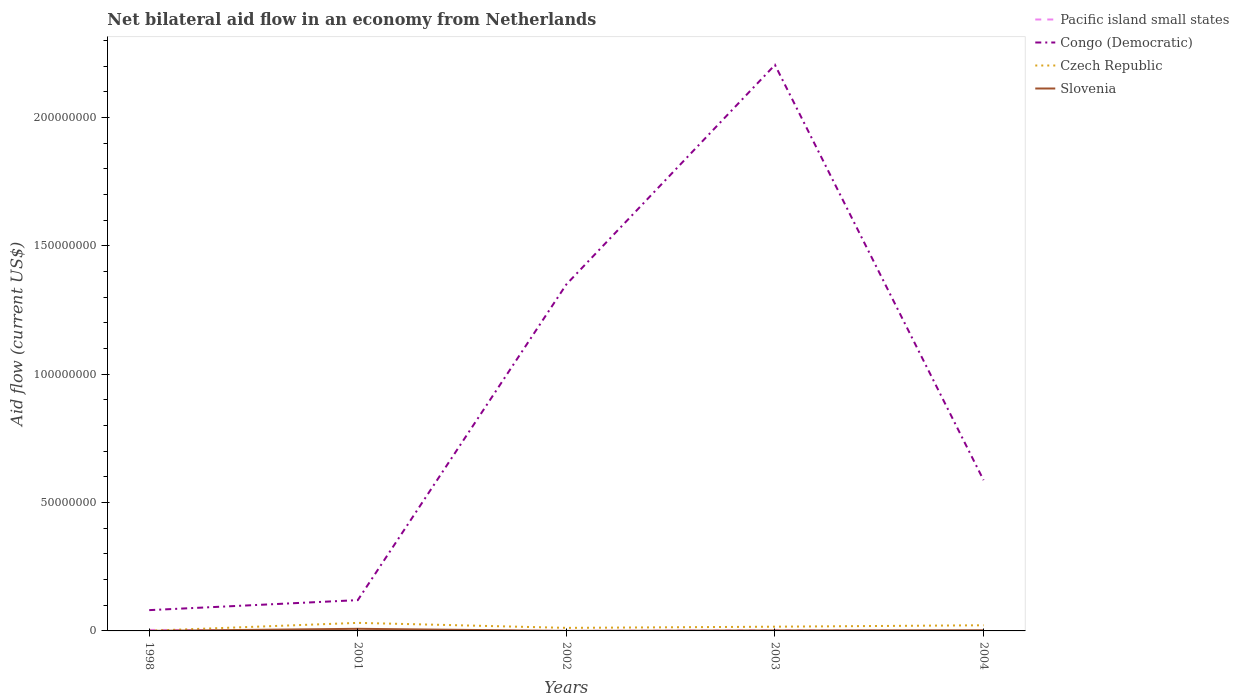How many different coloured lines are there?
Give a very brief answer. 4. Across all years, what is the maximum net bilateral aid flow in Slovenia?
Offer a terse response. 10000. What is the total net bilateral aid flow in Slovenia in the graph?
Make the answer very short. 5.60e+05. What is the difference between the highest and the lowest net bilateral aid flow in Czech Republic?
Make the answer very short. 2. How many years are there in the graph?
Provide a short and direct response. 5. Does the graph contain grids?
Give a very brief answer. No. Where does the legend appear in the graph?
Provide a succinct answer. Top right. What is the title of the graph?
Offer a terse response. Net bilateral aid flow in an economy from Netherlands. What is the label or title of the X-axis?
Give a very brief answer. Years. What is the Aid flow (current US$) in Pacific island small states in 1998?
Your response must be concise. 3.90e+05. What is the Aid flow (current US$) of Congo (Democratic) in 1998?
Provide a short and direct response. 8.10e+06. What is the Aid flow (current US$) in Czech Republic in 1998?
Offer a very short reply. 7.00e+04. What is the Aid flow (current US$) of Pacific island small states in 2001?
Provide a succinct answer. 1.80e+05. What is the Aid flow (current US$) of Congo (Democratic) in 2001?
Provide a short and direct response. 1.20e+07. What is the Aid flow (current US$) in Czech Republic in 2001?
Provide a short and direct response. 3.14e+06. What is the Aid flow (current US$) of Slovenia in 2001?
Make the answer very short. 8.20e+05. What is the Aid flow (current US$) in Pacific island small states in 2002?
Offer a very short reply. 10000. What is the Aid flow (current US$) of Congo (Democratic) in 2002?
Make the answer very short. 1.35e+08. What is the Aid flow (current US$) of Czech Republic in 2002?
Provide a succinct answer. 1.19e+06. What is the Aid flow (current US$) in Slovenia in 2002?
Provide a succinct answer. 10000. What is the Aid flow (current US$) in Congo (Democratic) in 2003?
Offer a terse response. 2.21e+08. What is the Aid flow (current US$) in Czech Republic in 2003?
Keep it short and to the point. 1.65e+06. What is the Aid flow (current US$) in Slovenia in 2003?
Provide a short and direct response. 1.90e+05. What is the Aid flow (current US$) of Pacific island small states in 2004?
Your answer should be very brief. 0. What is the Aid flow (current US$) in Congo (Democratic) in 2004?
Keep it short and to the point. 5.88e+07. What is the Aid flow (current US$) of Czech Republic in 2004?
Ensure brevity in your answer.  2.20e+06. Across all years, what is the maximum Aid flow (current US$) of Congo (Democratic)?
Ensure brevity in your answer.  2.21e+08. Across all years, what is the maximum Aid flow (current US$) in Czech Republic?
Ensure brevity in your answer.  3.14e+06. Across all years, what is the maximum Aid flow (current US$) of Slovenia?
Ensure brevity in your answer.  8.20e+05. Across all years, what is the minimum Aid flow (current US$) in Congo (Democratic)?
Ensure brevity in your answer.  8.10e+06. Across all years, what is the minimum Aid flow (current US$) in Slovenia?
Your answer should be very brief. 10000. What is the total Aid flow (current US$) of Pacific island small states in the graph?
Give a very brief answer. 7.60e+05. What is the total Aid flow (current US$) of Congo (Democratic) in the graph?
Your response must be concise. 4.34e+08. What is the total Aid flow (current US$) of Czech Republic in the graph?
Keep it short and to the point. 8.25e+06. What is the total Aid flow (current US$) of Slovenia in the graph?
Keep it short and to the point. 1.29e+06. What is the difference between the Aid flow (current US$) in Congo (Democratic) in 1998 and that in 2001?
Keep it short and to the point. -3.90e+06. What is the difference between the Aid flow (current US$) of Czech Republic in 1998 and that in 2001?
Your answer should be very brief. -3.07e+06. What is the difference between the Aid flow (current US$) in Slovenia in 1998 and that in 2001?
Keep it short and to the point. -8.10e+05. What is the difference between the Aid flow (current US$) of Congo (Democratic) in 1998 and that in 2002?
Make the answer very short. -1.27e+08. What is the difference between the Aid flow (current US$) in Czech Republic in 1998 and that in 2002?
Offer a very short reply. -1.12e+06. What is the difference between the Aid flow (current US$) of Congo (Democratic) in 1998 and that in 2003?
Provide a succinct answer. -2.12e+08. What is the difference between the Aid flow (current US$) of Czech Republic in 1998 and that in 2003?
Keep it short and to the point. -1.58e+06. What is the difference between the Aid flow (current US$) of Congo (Democratic) in 1998 and that in 2004?
Your answer should be very brief. -5.06e+07. What is the difference between the Aid flow (current US$) of Czech Republic in 1998 and that in 2004?
Offer a very short reply. -2.13e+06. What is the difference between the Aid flow (current US$) in Pacific island small states in 2001 and that in 2002?
Give a very brief answer. 1.70e+05. What is the difference between the Aid flow (current US$) in Congo (Democratic) in 2001 and that in 2002?
Provide a succinct answer. -1.23e+08. What is the difference between the Aid flow (current US$) of Czech Republic in 2001 and that in 2002?
Make the answer very short. 1.95e+06. What is the difference between the Aid flow (current US$) of Slovenia in 2001 and that in 2002?
Offer a very short reply. 8.10e+05. What is the difference between the Aid flow (current US$) of Pacific island small states in 2001 and that in 2003?
Ensure brevity in your answer.  0. What is the difference between the Aid flow (current US$) in Congo (Democratic) in 2001 and that in 2003?
Offer a terse response. -2.09e+08. What is the difference between the Aid flow (current US$) of Czech Republic in 2001 and that in 2003?
Offer a very short reply. 1.49e+06. What is the difference between the Aid flow (current US$) in Slovenia in 2001 and that in 2003?
Make the answer very short. 6.30e+05. What is the difference between the Aid flow (current US$) in Congo (Democratic) in 2001 and that in 2004?
Offer a terse response. -4.68e+07. What is the difference between the Aid flow (current US$) of Czech Republic in 2001 and that in 2004?
Your answer should be compact. 9.40e+05. What is the difference between the Aid flow (current US$) in Slovenia in 2001 and that in 2004?
Provide a short and direct response. 5.60e+05. What is the difference between the Aid flow (current US$) in Pacific island small states in 2002 and that in 2003?
Keep it short and to the point. -1.70e+05. What is the difference between the Aid flow (current US$) in Congo (Democratic) in 2002 and that in 2003?
Offer a very short reply. -8.55e+07. What is the difference between the Aid flow (current US$) of Czech Republic in 2002 and that in 2003?
Your answer should be very brief. -4.60e+05. What is the difference between the Aid flow (current US$) of Slovenia in 2002 and that in 2003?
Offer a terse response. -1.80e+05. What is the difference between the Aid flow (current US$) of Congo (Democratic) in 2002 and that in 2004?
Provide a succinct answer. 7.63e+07. What is the difference between the Aid flow (current US$) in Czech Republic in 2002 and that in 2004?
Provide a short and direct response. -1.01e+06. What is the difference between the Aid flow (current US$) in Congo (Democratic) in 2003 and that in 2004?
Offer a terse response. 1.62e+08. What is the difference between the Aid flow (current US$) in Czech Republic in 2003 and that in 2004?
Your answer should be compact. -5.50e+05. What is the difference between the Aid flow (current US$) of Slovenia in 2003 and that in 2004?
Give a very brief answer. -7.00e+04. What is the difference between the Aid flow (current US$) of Pacific island small states in 1998 and the Aid flow (current US$) of Congo (Democratic) in 2001?
Keep it short and to the point. -1.16e+07. What is the difference between the Aid flow (current US$) in Pacific island small states in 1998 and the Aid flow (current US$) in Czech Republic in 2001?
Your answer should be very brief. -2.75e+06. What is the difference between the Aid flow (current US$) in Pacific island small states in 1998 and the Aid flow (current US$) in Slovenia in 2001?
Provide a succinct answer. -4.30e+05. What is the difference between the Aid flow (current US$) of Congo (Democratic) in 1998 and the Aid flow (current US$) of Czech Republic in 2001?
Offer a very short reply. 4.96e+06. What is the difference between the Aid flow (current US$) of Congo (Democratic) in 1998 and the Aid flow (current US$) of Slovenia in 2001?
Provide a short and direct response. 7.28e+06. What is the difference between the Aid flow (current US$) of Czech Republic in 1998 and the Aid flow (current US$) of Slovenia in 2001?
Your response must be concise. -7.50e+05. What is the difference between the Aid flow (current US$) in Pacific island small states in 1998 and the Aid flow (current US$) in Congo (Democratic) in 2002?
Keep it short and to the point. -1.35e+08. What is the difference between the Aid flow (current US$) in Pacific island small states in 1998 and the Aid flow (current US$) in Czech Republic in 2002?
Offer a very short reply. -8.00e+05. What is the difference between the Aid flow (current US$) in Congo (Democratic) in 1998 and the Aid flow (current US$) in Czech Republic in 2002?
Provide a short and direct response. 6.91e+06. What is the difference between the Aid flow (current US$) in Congo (Democratic) in 1998 and the Aid flow (current US$) in Slovenia in 2002?
Your answer should be compact. 8.09e+06. What is the difference between the Aid flow (current US$) in Pacific island small states in 1998 and the Aid flow (current US$) in Congo (Democratic) in 2003?
Keep it short and to the point. -2.20e+08. What is the difference between the Aid flow (current US$) of Pacific island small states in 1998 and the Aid flow (current US$) of Czech Republic in 2003?
Give a very brief answer. -1.26e+06. What is the difference between the Aid flow (current US$) in Congo (Democratic) in 1998 and the Aid flow (current US$) in Czech Republic in 2003?
Keep it short and to the point. 6.45e+06. What is the difference between the Aid flow (current US$) of Congo (Democratic) in 1998 and the Aid flow (current US$) of Slovenia in 2003?
Make the answer very short. 7.91e+06. What is the difference between the Aid flow (current US$) of Czech Republic in 1998 and the Aid flow (current US$) of Slovenia in 2003?
Offer a terse response. -1.20e+05. What is the difference between the Aid flow (current US$) of Pacific island small states in 1998 and the Aid flow (current US$) of Congo (Democratic) in 2004?
Keep it short and to the point. -5.84e+07. What is the difference between the Aid flow (current US$) in Pacific island small states in 1998 and the Aid flow (current US$) in Czech Republic in 2004?
Offer a very short reply. -1.81e+06. What is the difference between the Aid flow (current US$) in Congo (Democratic) in 1998 and the Aid flow (current US$) in Czech Republic in 2004?
Provide a succinct answer. 5.90e+06. What is the difference between the Aid flow (current US$) of Congo (Democratic) in 1998 and the Aid flow (current US$) of Slovenia in 2004?
Your response must be concise. 7.84e+06. What is the difference between the Aid flow (current US$) of Pacific island small states in 2001 and the Aid flow (current US$) of Congo (Democratic) in 2002?
Offer a terse response. -1.35e+08. What is the difference between the Aid flow (current US$) in Pacific island small states in 2001 and the Aid flow (current US$) in Czech Republic in 2002?
Keep it short and to the point. -1.01e+06. What is the difference between the Aid flow (current US$) of Congo (Democratic) in 2001 and the Aid flow (current US$) of Czech Republic in 2002?
Your answer should be compact. 1.08e+07. What is the difference between the Aid flow (current US$) in Congo (Democratic) in 2001 and the Aid flow (current US$) in Slovenia in 2002?
Your response must be concise. 1.20e+07. What is the difference between the Aid flow (current US$) in Czech Republic in 2001 and the Aid flow (current US$) in Slovenia in 2002?
Offer a terse response. 3.13e+06. What is the difference between the Aid flow (current US$) of Pacific island small states in 2001 and the Aid flow (current US$) of Congo (Democratic) in 2003?
Keep it short and to the point. -2.20e+08. What is the difference between the Aid flow (current US$) in Pacific island small states in 2001 and the Aid flow (current US$) in Czech Republic in 2003?
Offer a terse response. -1.47e+06. What is the difference between the Aid flow (current US$) in Pacific island small states in 2001 and the Aid flow (current US$) in Slovenia in 2003?
Offer a terse response. -10000. What is the difference between the Aid flow (current US$) of Congo (Democratic) in 2001 and the Aid flow (current US$) of Czech Republic in 2003?
Provide a succinct answer. 1.04e+07. What is the difference between the Aid flow (current US$) in Congo (Democratic) in 2001 and the Aid flow (current US$) in Slovenia in 2003?
Offer a very short reply. 1.18e+07. What is the difference between the Aid flow (current US$) of Czech Republic in 2001 and the Aid flow (current US$) of Slovenia in 2003?
Offer a very short reply. 2.95e+06. What is the difference between the Aid flow (current US$) in Pacific island small states in 2001 and the Aid flow (current US$) in Congo (Democratic) in 2004?
Offer a very short reply. -5.86e+07. What is the difference between the Aid flow (current US$) in Pacific island small states in 2001 and the Aid flow (current US$) in Czech Republic in 2004?
Make the answer very short. -2.02e+06. What is the difference between the Aid flow (current US$) in Congo (Democratic) in 2001 and the Aid flow (current US$) in Czech Republic in 2004?
Provide a short and direct response. 9.80e+06. What is the difference between the Aid flow (current US$) of Congo (Democratic) in 2001 and the Aid flow (current US$) of Slovenia in 2004?
Your answer should be very brief. 1.17e+07. What is the difference between the Aid flow (current US$) in Czech Republic in 2001 and the Aid flow (current US$) in Slovenia in 2004?
Offer a terse response. 2.88e+06. What is the difference between the Aid flow (current US$) in Pacific island small states in 2002 and the Aid flow (current US$) in Congo (Democratic) in 2003?
Offer a terse response. -2.21e+08. What is the difference between the Aid flow (current US$) in Pacific island small states in 2002 and the Aid flow (current US$) in Czech Republic in 2003?
Provide a succinct answer. -1.64e+06. What is the difference between the Aid flow (current US$) of Pacific island small states in 2002 and the Aid flow (current US$) of Slovenia in 2003?
Provide a short and direct response. -1.80e+05. What is the difference between the Aid flow (current US$) of Congo (Democratic) in 2002 and the Aid flow (current US$) of Czech Republic in 2003?
Make the answer very short. 1.33e+08. What is the difference between the Aid flow (current US$) in Congo (Democratic) in 2002 and the Aid flow (current US$) in Slovenia in 2003?
Give a very brief answer. 1.35e+08. What is the difference between the Aid flow (current US$) in Pacific island small states in 2002 and the Aid flow (current US$) in Congo (Democratic) in 2004?
Give a very brief answer. -5.87e+07. What is the difference between the Aid flow (current US$) in Pacific island small states in 2002 and the Aid flow (current US$) in Czech Republic in 2004?
Ensure brevity in your answer.  -2.19e+06. What is the difference between the Aid flow (current US$) of Pacific island small states in 2002 and the Aid flow (current US$) of Slovenia in 2004?
Your response must be concise. -2.50e+05. What is the difference between the Aid flow (current US$) of Congo (Democratic) in 2002 and the Aid flow (current US$) of Czech Republic in 2004?
Offer a very short reply. 1.33e+08. What is the difference between the Aid flow (current US$) in Congo (Democratic) in 2002 and the Aid flow (current US$) in Slovenia in 2004?
Give a very brief answer. 1.35e+08. What is the difference between the Aid flow (current US$) in Czech Republic in 2002 and the Aid flow (current US$) in Slovenia in 2004?
Keep it short and to the point. 9.30e+05. What is the difference between the Aid flow (current US$) in Pacific island small states in 2003 and the Aid flow (current US$) in Congo (Democratic) in 2004?
Keep it short and to the point. -5.86e+07. What is the difference between the Aid flow (current US$) of Pacific island small states in 2003 and the Aid flow (current US$) of Czech Republic in 2004?
Offer a terse response. -2.02e+06. What is the difference between the Aid flow (current US$) of Congo (Democratic) in 2003 and the Aid flow (current US$) of Czech Republic in 2004?
Offer a very short reply. 2.18e+08. What is the difference between the Aid flow (current US$) in Congo (Democratic) in 2003 and the Aid flow (current US$) in Slovenia in 2004?
Offer a very short reply. 2.20e+08. What is the difference between the Aid flow (current US$) in Czech Republic in 2003 and the Aid flow (current US$) in Slovenia in 2004?
Make the answer very short. 1.39e+06. What is the average Aid flow (current US$) in Pacific island small states per year?
Offer a very short reply. 1.52e+05. What is the average Aid flow (current US$) of Congo (Democratic) per year?
Offer a terse response. 8.69e+07. What is the average Aid flow (current US$) in Czech Republic per year?
Give a very brief answer. 1.65e+06. What is the average Aid flow (current US$) of Slovenia per year?
Give a very brief answer. 2.58e+05. In the year 1998, what is the difference between the Aid flow (current US$) in Pacific island small states and Aid flow (current US$) in Congo (Democratic)?
Provide a short and direct response. -7.71e+06. In the year 1998, what is the difference between the Aid flow (current US$) in Congo (Democratic) and Aid flow (current US$) in Czech Republic?
Offer a very short reply. 8.03e+06. In the year 1998, what is the difference between the Aid flow (current US$) in Congo (Democratic) and Aid flow (current US$) in Slovenia?
Offer a terse response. 8.09e+06. In the year 2001, what is the difference between the Aid flow (current US$) in Pacific island small states and Aid flow (current US$) in Congo (Democratic)?
Give a very brief answer. -1.18e+07. In the year 2001, what is the difference between the Aid flow (current US$) of Pacific island small states and Aid flow (current US$) of Czech Republic?
Give a very brief answer. -2.96e+06. In the year 2001, what is the difference between the Aid flow (current US$) of Pacific island small states and Aid flow (current US$) of Slovenia?
Give a very brief answer. -6.40e+05. In the year 2001, what is the difference between the Aid flow (current US$) of Congo (Democratic) and Aid flow (current US$) of Czech Republic?
Keep it short and to the point. 8.86e+06. In the year 2001, what is the difference between the Aid flow (current US$) of Congo (Democratic) and Aid flow (current US$) of Slovenia?
Offer a very short reply. 1.12e+07. In the year 2001, what is the difference between the Aid flow (current US$) in Czech Republic and Aid flow (current US$) in Slovenia?
Keep it short and to the point. 2.32e+06. In the year 2002, what is the difference between the Aid flow (current US$) in Pacific island small states and Aid flow (current US$) in Congo (Democratic)?
Offer a very short reply. -1.35e+08. In the year 2002, what is the difference between the Aid flow (current US$) in Pacific island small states and Aid flow (current US$) in Czech Republic?
Offer a terse response. -1.18e+06. In the year 2002, what is the difference between the Aid flow (current US$) in Congo (Democratic) and Aid flow (current US$) in Czech Republic?
Offer a very short reply. 1.34e+08. In the year 2002, what is the difference between the Aid flow (current US$) of Congo (Democratic) and Aid flow (current US$) of Slovenia?
Provide a short and direct response. 1.35e+08. In the year 2002, what is the difference between the Aid flow (current US$) in Czech Republic and Aid flow (current US$) in Slovenia?
Your response must be concise. 1.18e+06. In the year 2003, what is the difference between the Aid flow (current US$) of Pacific island small states and Aid flow (current US$) of Congo (Democratic)?
Offer a very short reply. -2.20e+08. In the year 2003, what is the difference between the Aid flow (current US$) in Pacific island small states and Aid flow (current US$) in Czech Republic?
Give a very brief answer. -1.47e+06. In the year 2003, what is the difference between the Aid flow (current US$) in Pacific island small states and Aid flow (current US$) in Slovenia?
Provide a short and direct response. -10000. In the year 2003, what is the difference between the Aid flow (current US$) in Congo (Democratic) and Aid flow (current US$) in Czech Republic?
Make the answer very short. 2.19e+08. In the year 2003, what is the difference between the Aid flow (current US$) in Congo (Democratic) and Aid flow (current US$) in Slovenia?
Make the answer very short. 2.20e+08. In the year 2003, what is the difference between the Aid flow (current US$) in Czech Republic and Aid flow (current US$) in Slovenia?
Ensure brevity in your answer.  1.46e+06. In the year 2004, what is the difference between the Aid flow (current US$) of Congo (Democratic) and Aid flow (current US$) of Czech Republic?
Make the answer very short. 5.66e+07. In the year 2004, what is the difference between the Aid flow (current US$) of Congo (Democratic) and Aid flow (current US$) of Slovenia?
Make the answer very short. 5.85e+07. In the year 2004, what is the difference between the Aid flow (current US$) of Czech Republic and Aid flow (current US$) of Slovenia?
Your response must be concise. 1.94e+06. What is the ratio of the Aid flow (current US$) of Pacific island small states in 1998 to that in 2001?
Offer a terse response. 2.17. What is the ratio of the Aid flow (current US$) of Congo (Democratic) in 1998 to that in 2001?
Your response must be concise. 0.68. What is the ratio of the Aid flow (current US$) of Czech Republic in 1998 to that in 2001?
Offer a very short reply. 0.02. What is the ratio of the Aid flow (current US$) of Slovenia in 1998 to that in 2001?
Provide a succinct answer. 0.01. What is the ratio of the Aid flow (current US$) in Congo (Democratic) in 1998 to that in 2002?
Make the answer very short. 0.06. What is the ratio of the Aid flow (current US$) in Czech Republic in 1998 to that in 2002?
Your response must be concise. 0.06. What is the ratio of the Aid flow (current US$) in Slovenia in 1998 to that in 2002?
Offer a very short reply. 1. What is the ratio of the Aid flow (current US$) of Pacific island small states in 1998 to that in 2003?
Make the answer very short. 2.17. What is the ratio of the Aid flow (current US$) in Congo (Democratic) in 1998 to that in 2003?
Your answer should be very brief. 0.04. What is the ratio of the Aid flow (current US$) in Czech Republic in 1998 to that in 2003?
Provide a short and direct response. 0.04. What is the ratio of the Aid flow (current US$) in Slovenia in 1998 to that in 2003?
Ensure brevity in your answer.  0.05. What is the ratio of the Aid flow (current US$) in Congo (Democratic) in 1998 to that in 2004?
Offer a terse response. 0.14. What is the ratio of the Aid flow (current US$) of Czech Republic in 1998 to that in 2004?
Your response must be concise. 0.03. What is the ratio of the Aid flow (current US$) of Slovenia in 1998 to that in 2004?
Give a very brief answer. 0.04. What is the ratio of the Aid flow (current US$) of Pacific island small states in 2001 to that in 2002?
Provide a succinct answer. 18. What is the ratio of the Aid flow (current US$) of Congo (Democratic) in 2001 to that in 2002?
Keep it short and to the point. 0.09. What is the ratio of the Aid flow (current US$) in Czech Republic in 2001 to that in 2002?
Make the answer very short. 2.64. What is the ratio of the Aid flow (current US$) in Congo (Democratic) in 2001 to that in 2003?
Provide a short and direct response. 0.05. What is the ratio of the Aid flow (current US$) in Czech Republic in 2001 to that in 2003?
Provide a succinct answer. 1.9. What is the ratio of the Aid flow (current US$) in Slovenia in 2001 to that in 2003?
Your answer should be very brief. 4.32. What is the ratio of the Aid flow (current US$) of Congo (Democratic) in 2001 to that in 2004?
Your response must be concise. 0.2. What is the ratio of the Aid flow (current US$) of Czech Republic in 2001 to that in 2004?
Give a very brief answer. 1.43. What is the ratio of the Aid flow (current US$) of Slovenia in 2001 to that in 2004?
Ensure brevity in your answer.  3.15. What is the ratio of the Aid flow (current US$) of Pacific island small states in 2002 to that in 2003?
Give a very brief answer. 0.06. What is the ratio of the Aid flow (current US$) in Congo (Democratic) in 2002 to that in 2003?
Make the answer very short. 0.61. What is the ratio of the Aid flow (current US$) in Czech Republic in 2002 to that in 2003?
Ensure brevity in your answer.  0.72. What is the ratio of the Aid flow (current US$) in Slovenia in 2002 to that in 2003?
Provide a short and direct response. 0.05. What is the ratio of the Aid flow (current US$) of Congo (Democratic) in 2002 to that in 2004?
Offer a terse response. 2.3. What is the ratio of the Aid flow (current US$) of Czech Republic in 2002 to that in 2004?
Your answer should be very brief. 0.54. What is the ratio of the Aid flow (current US$) of Slovenia in 2002 to that in 2004?
Make the answer very short. 0.04. What is the ratio of the Aid flow (current US$) in Congo (Democratic) in 2003 to that in 2004?
Your answer should be very brief. 3.75. What is the ratio of the Aid flow (current US$) of Czech Republic in 2003 to that in 2004?
Your answer should be very brief. 0.75. What is the ratio of the Aid flow (current US$) of Slovenia in 2003 to that in 2004?
Your answer should be very brief. 0.73. What is the difference between the highest and the second highest Aid flow (current US$) in Pacific island small states?
Your answer should be compact. 2.10e+05. What is the difference between the highest and the second highest Aid flow (current US$) of Congo (Democratic)?
Provide a succinct answer. 8.55e+07. What is the difference between the highest and the second highest Aid flow (current US$) of Czech Republic?
Your answer should be compact. 9.40e+05. What is the difference between the highest and the second highest Aid flow (current US$) of Slovenia?
Provide a short and direct response. 5.60e+05. What is the difference between the highest and the lowest Aid flow (current US$) of Congo (Democratic)?
Your response must be concise. 2.12e+08. What is the difference between the highest and the lowest Aid flow (current US$) of Czech Republic?
Offer a terse response. 3.07e+06. What is the difference between the highest and the lowest Aid flow (current US$) in Slovenia?
Provide a succinct answer. 8.10e+05. 